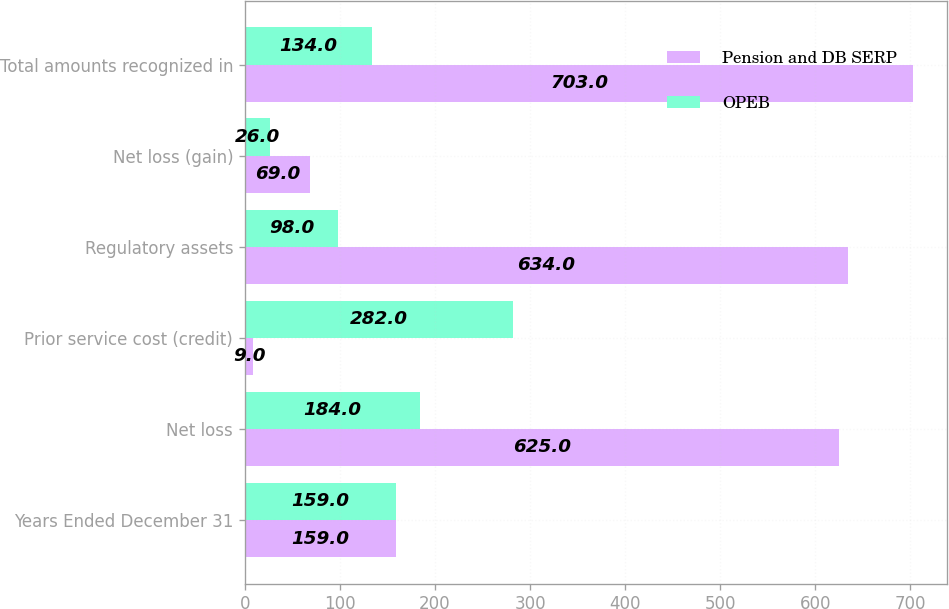<chart> <loc_0><loc_0><loc_500><loc_500><stacked_bar_chart><ecel><fcel>Years Ended December 31<fcel>Net loss<fcel>Prior service cost (credit)<fcel>Regulatory assets<fcel>Net loss (gain)<fcel>Total amounts recognized in<nl><fcel>Pension and DB SERP<fcel>159<fcel>625<fcel>9<fcel>634<fcel>69<fcel>703<nl><fcel>OPEB<fcel>159<fcel>184<fcel>282<fcel>98<fcel>26<fcel>134<nl></chart> 